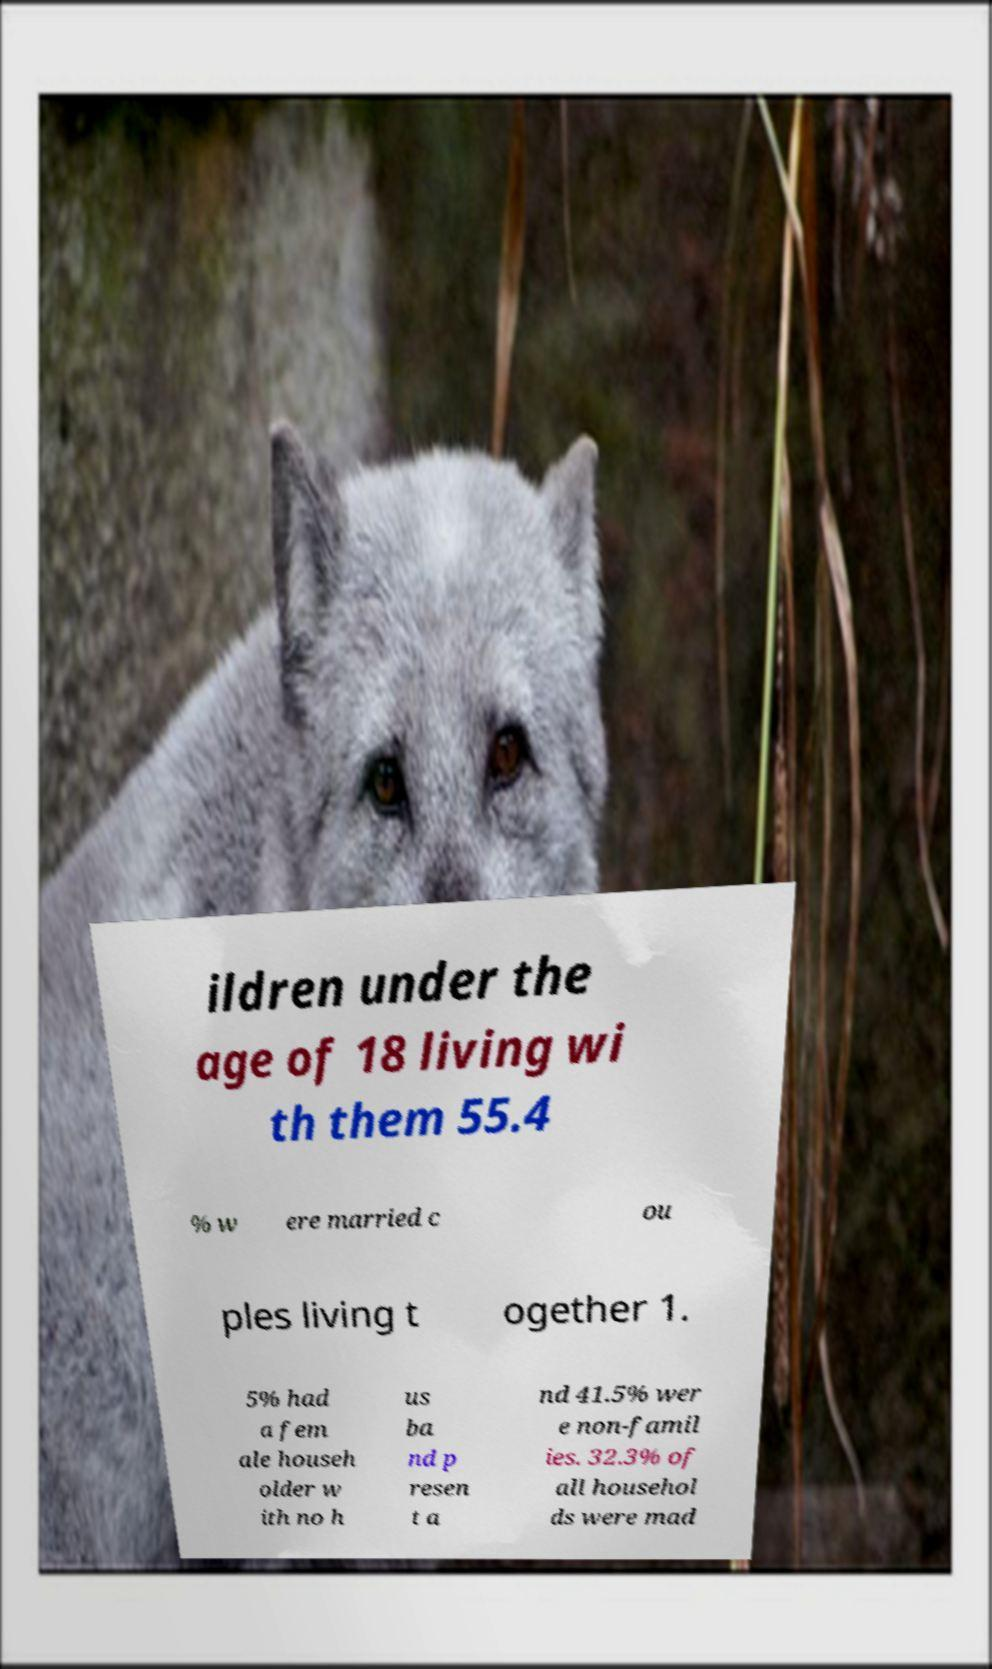Please identify and transcribe the text found in this image. ildren under the age of 18 living wi th them 55.4 % w ere married c ou ples living t ogether 1. 5% had a fem ale househ older w ith no h us ba nd p resen t a nd 41.5% wer e non-famil ies. 32.3% of all househol ds were mad 